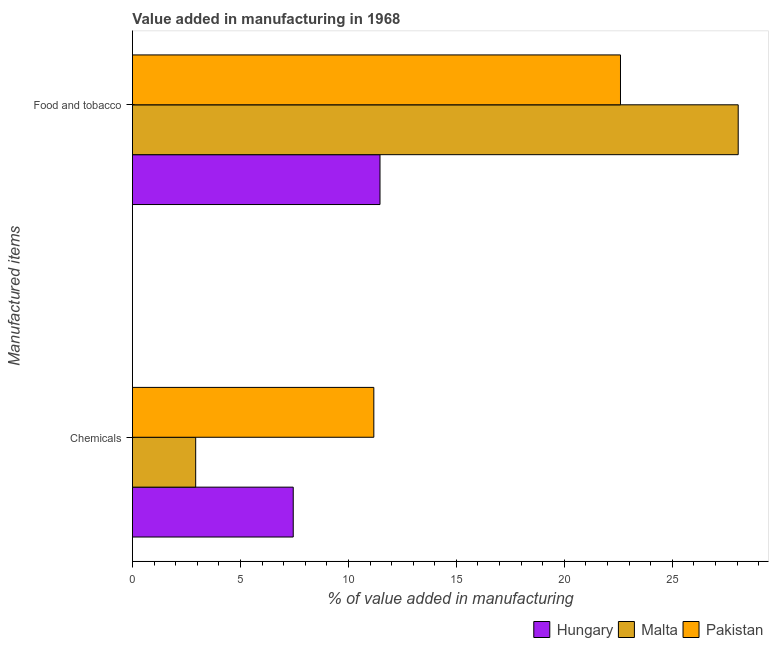How many groups of bars are there?
Keep it short and to the point. 2. Are the number of bars per tick equal to the number of legend labels?
Ensure brevity in your answer.  Yes. Are the number of bars on each tick of the Y-axis equal?
Provide a short and direct response. Yes. How many bars are there on the 1st tick from the top?
Provide a succinct answer. 3. What is the label of the 2nd group of bars from the top?
Give a very brief answer. Chemicals. What is the value added by  manufacturing chemicals in Pakistan?
Keep it short and to the point. 11.18. Across all countries, what is the maximum value added by manufacturing food and tobacco?
Your answer should be very brief. 28.05. Across all countries, what is the minimum value added by  manufacturing chemicals?
Ensure brevity in your answer.  2.93. In which country was the value added by  manufacturing chemicals minimum?
Provide a succinct answer. Malta. What is the total value added by  manufacturing chemicals in the graph?
Provide a short and direct response. 21.55. What is the difference between the value added by manufacturing food and tobacco in Hungary and that in Pakistan?
Offer a very short reply. -11.13. What is the difference between the value added by  manufacturing chemicals in Malta and the value added by manufacturing food and tobacco in Hungary?
Provide a succinct answer. -8.53. What is the average value added by  manufacturing chemicals per country?
Keep it short and to the point. 7.18. What is the difference between the value added by  manufacturing chemicals and value added by manufacturing food and tobacco in Malta?
Offer a terse response. -25.12. What is the ratio of the value added by manufacturing food and tobacco in Pakistan to that in Hungary?
Provide a short and direct response. 1.97. Is the value added by manufacturing food and tobacco in Pakistan less than that in Malta?
Your response must be concise. Yes. What does the 3rd bar from the bottom in Chemicals represents?
Your answer should be very brief. Pakistan. How many countries are there in the graph?
Give a very brief answer. 3. Are the values on the major ticks of X-axis written in scientific E-notation?
Your response must be concise. No. Where does the legend appear in the graph?
Make the answer very short. Bottom right. What is the title of the graph?
Keep it short and to the point. Value added in manufacturing in 1968. What is the label or title of the X-axis?
Your response must be concise. % of value added in manufacturing. What is the label or title of the Y-axis?
Give a very brief answer. Manufactured items. What is the % of value added in manufacturing of Hungary in Chemicals?
Make the answer very short. 7.45. What is the % of value added in manufacturing in Malta in Chemicals?
Give a very brief answer. 2.93. What is the % of value added in manufacturing in Pakistan in Chemicals?
Give a very brief answer. 11.18. What is the % of value added in manufacturing of Hungary in Food and tobacco?
Provide a short and direct response. 11.46. What is the % of value added in manufacturing in Malta in Food and tobacco?
Make the answer very short. 28.05. What is the % of value added in manufacturing in Pakistan in Food and tobacco?
Your answer should be very brief. 22.6. Across all Manufactured items, what is the maximum % of value added in manufacturing of Hungary?
Your response must be concise. 11.46. Across all Manufactured items, what is the maximum % of value added in manufacturing of Malta?
Offer a very short reply. 28.05. Across all Manufactured items, what is the maximum % of value added in manufacturing of Pakistan?
Your answer should be compact. 22.6. Across all Manufactured items, what is the minimum % of value added in manufacturing in Hungary?
Give a very brief answer. 7.45. Across all Manufactured items, what is the minimum % of value added in manufacturing in Malta?
Your answer should be very brief. 2.93. Across all Manufactured items, what is the minimum % of value added in manufacturing of Pakistan?
Your answer should be compact. 11.18. What is the total % of value added in manufacturing in Hungary in the graph?
Make the answer very short. 18.91. What is the total % of value added in manufacturing of Malta in the graph?
Offer a very short reply. 30.98. What is the total % of value added in manufacturing of Pakistan in the graph?
Your answer should be compact. 33.78. What is the difference between the % of value added in manufacturing in Hungary in Chemicals and that in Food and tobacco?
Your response must be concise. -4.02. What is the difference between the % of value added in manufacturing of Malta in Chemicals and that in Food and tobacco?
Keep it short and to the point. -25.12. What is the difference between the % of value added in manufacturing in Pakistan in Chemicals and that in Food and tobacco?
Keep it short and to the point. -11.42. What is the difference between the % of value added in manufacturing of Hungary in Chemicals and the % of value added in manufacturing of Malta in Food and tobacco?
Make the answer very short. -20.6. What is the difference between the % of value added in manufacturing of Hungary in Chemicals and the % of value added in manufacturing of Pakistan in Food and tobacco?
Offer a terse response. -15.15. What is the difference between the % of value added in manufacturing in Malta in Chemicals and the % of value added in manufacturing in Pakistan in Food and tobacco?
Give a very brief answer. -19.67. What is the average % of value added in manufacturing of Hungary per Manufactured items?
Ensure brevity in your answer.  9.45. What is the average % of value added in manufacturing of Malta per Manufactured items?
Your answer should be compact. 15.49. What is the average % of value added in manufacturing in Pakistan per Manufactured items?
Your response must be concise. 16.89. What is the difference between the % of value added in manufacturing of Hungary and % of value added in manufacturing of Malta in Chemicals?
Offer a terse response. 4.52. What is the difference between the % of value added in manufacturing of Hungary and % of value added in manufacturing of Pakistan in Chemicals?
Offer a very short reply. -3.73. What is the difference between the % of value added in manufacturing of Malta and % of value added in manufacturing of Pakistan in Chemicals?
Your answer should be very brief. -8.25. What is the difference between the % of value added in manufacturing of Hungary and % of value added in manufacturing of Malta in Food and tobacco?
Keep it short and to the point. -16.59. What is the difference between the % of value added in manufacturing in Hungary and % of value added in manufacturing in Pakistan in Food and tobacco?
Your response must be concise. -11.13. What is the difference between the % of value added in manufacturing of Malta and % of value added in manufacturing of Pakistan in Food and tobacco?
Give a very brief answer. 5.45. What is the ratio of the % of value added in manufacturing in Hungary in Chemicals to that in Food and tobacco?
Keep it short and to the point. 0.65. What is the ratio of the % of value added in manufacturing of Malta in Chemicals to that in Food and tobacco?
Your answer should be compact. 0.1. What is the ratio of the % of value added in manufacturing of Pakistan in Chemicals to that in Food and tobacco?
Offer a terse response. 0.49. What is the difference between the highest and the second highest % of value added in manufacturing of Hungary?
Keep it short and to the point. 4.02. What is the difference between the highest and the second highest % of value added in manufacturing of Malta?
Keep it short and to the point. 25.12. What is the difference between the highest and the second highest % of value added in manufacturing in Pakistan?
Offer a very short reply. 11.42. What is the difference between the highest and the lowest % of value added in manufacturing of Hungary?
Your response must be concise. 4.02. What is the difference between the highest and the lowest % of value added in manufacturing of Malta?
Your response must be concise. 25.12. What is the difference between the highest and the lowest % of value added in manufacturing in Pakistan?
Your response must be concise. 11.42. 